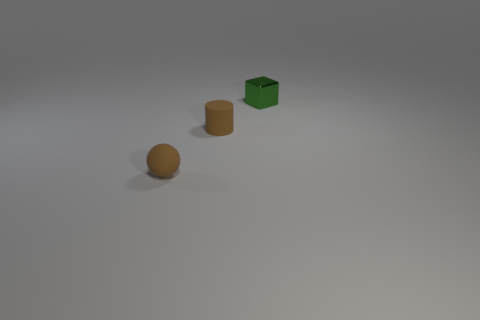If these objects were part of a game, what sort of game do they remind you of? These objects could belong to a minimalist puzzle or strategy game, where the goal might involve sorting or organizing the different shapes and colors according to specific rules or patterns. 